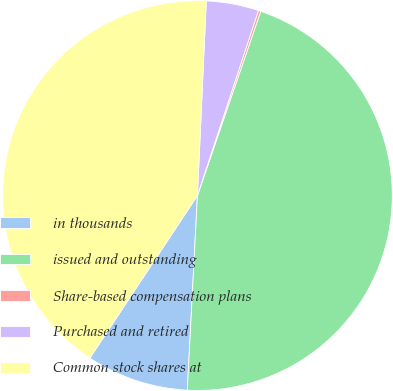Convert chart. <chart><loc_0><loc_0><loc_500><loc_500><pie_chart><fcel>in thousands<fcel>issued and outstanding<fcel>Share-based compensation plans<fcel>Purchased and retired<fcel>Common stock shares at<nl><fcel>8.48%<fcel>45.56%<fcel>0.2%<fcel>4.34%<fcel>41.42%<nl></chart> 